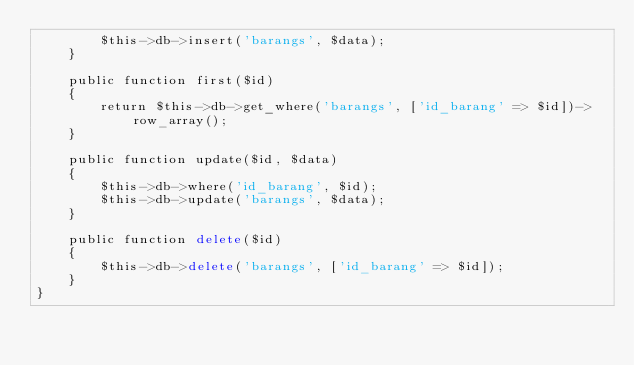Convert code to text. <code><loc_0><loc_0><loc_500><loc_500><_PHP_>        $this->db->insert('barangs', $data);
    }

    public function first($id)
    {
        return $this->db->get_where('barangs', ['id_barang' => $id])->row_array();
    }

    public function update($id, $data)
    {
        $this->db->where('id_barang', $id);
        $this->db->update('barangs', $data);
    }

    public function delete($id)
    {
        $this->db->delete('barangs', ['id_barang' => $id]);
    }
}
</code> 